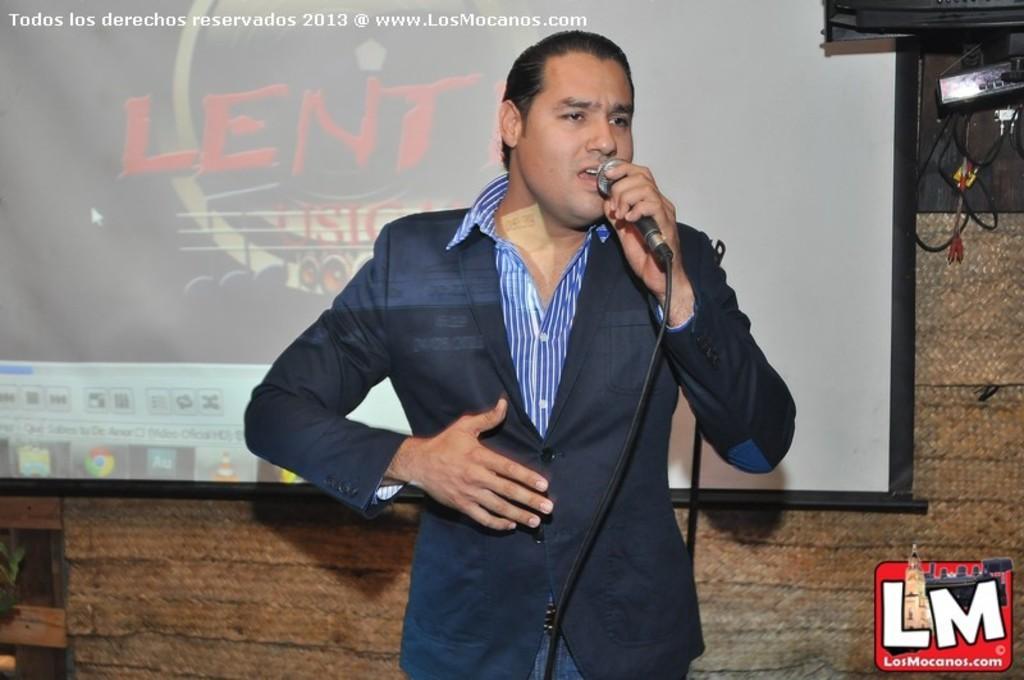Please provide a concise description of this image. This is the picture of a man in blazer holding a microphone and talking. Background of this man is a projector screen and wall. 